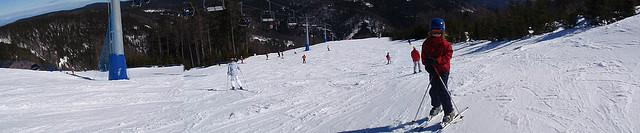What is a term used for this place? Please explain your reasoning. downhill. This is a place they can ski down. 